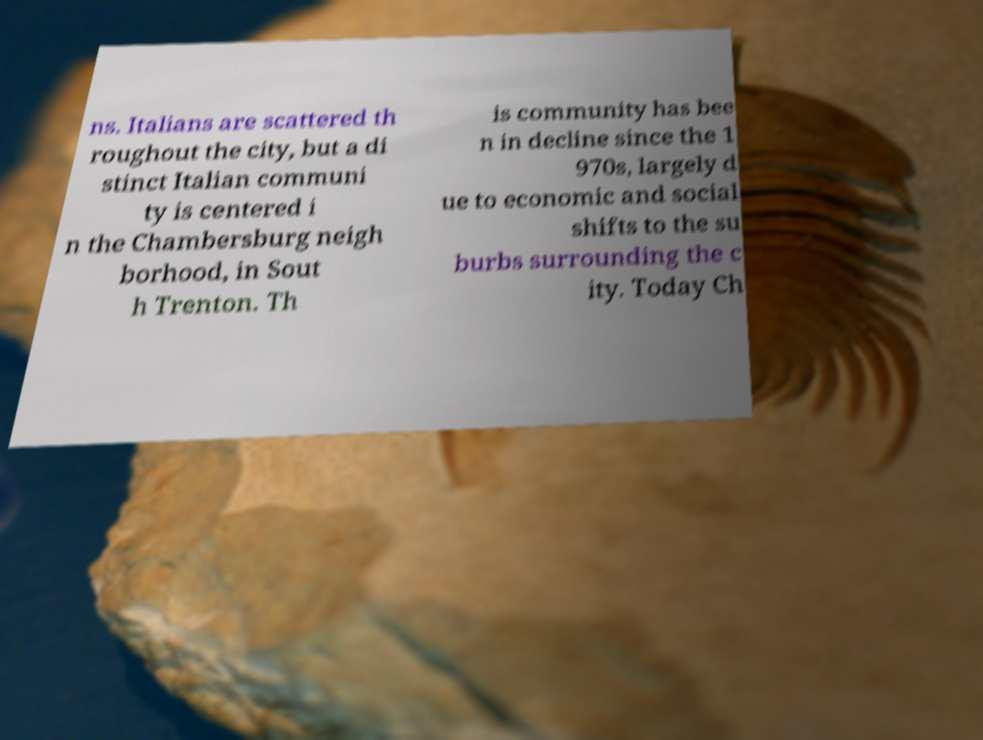What messages or text are displayed in this image? I need them in a readable, typed format. ns. Italians are scattered th roughout the city, but a di stinct Italian communi ty is centered i n the Chambersburg neigh borhood, in Sout h Trenton. Th is community has bee n in decline since the 1 970s, largely d ue to economic and social shifts to the su burbs surrounding the c ity. Today Ch 